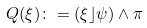Convert formula to latex. <formula><loc_0><loc_0><loc_500><loc_500>Q ( \xi ) \colon = ( \xi \rfloor \psi ) \wedge \pi \,</formula> 